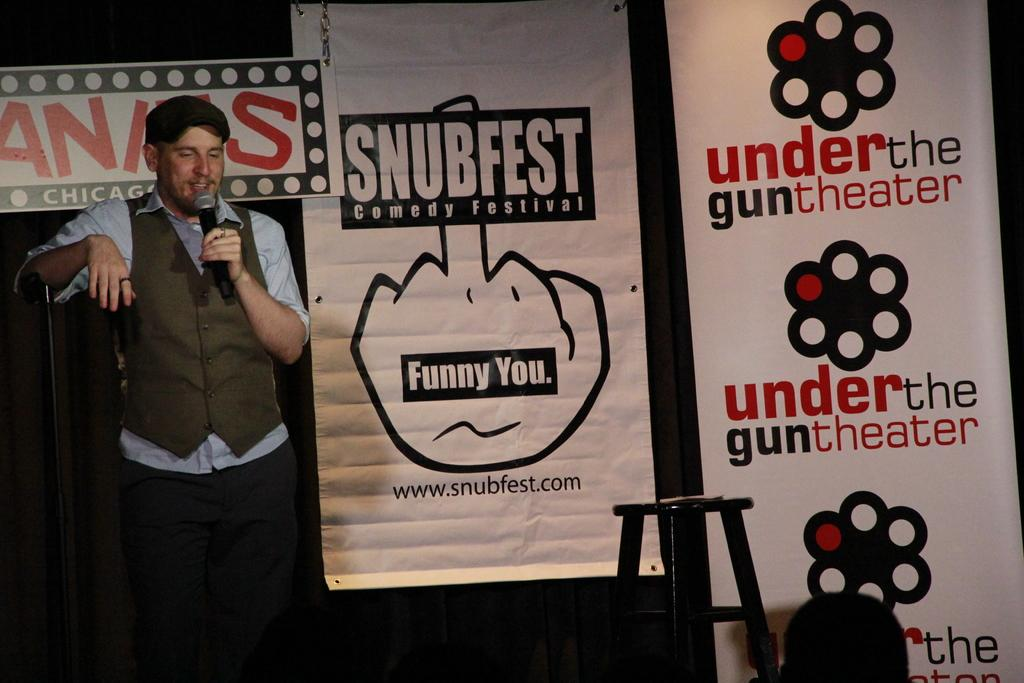What is the person in the image holding? The person is holding a microphone. What can be seen in the background of the image? There are hoardings and a table in the background. What is on the table in the image? There is an object on the table. What is written on the hoardings in the image? Something is written on the hoardings. What type of bulb is being used to illuminate the scene in the image? There is no bulb visible in the image, as it is focused on the person holding a microphone and the background elements. 